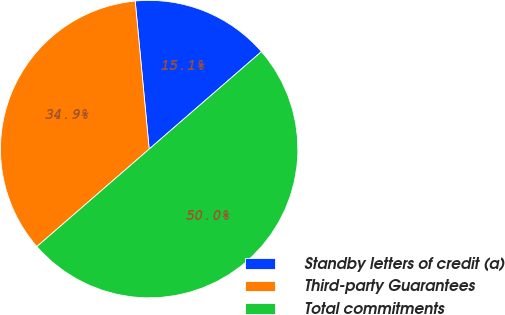Convert chart to OTSL. <chart><loc_0><loc_0><loc_500><loc_500><pie_chart><fcel>Standby letters of credit (a)<fcel>Third-party Guarantees<fcel>Total commitments<nl><fcel>15.12%<fcel>34.88%<fcel>50.0%<nl></chart> 